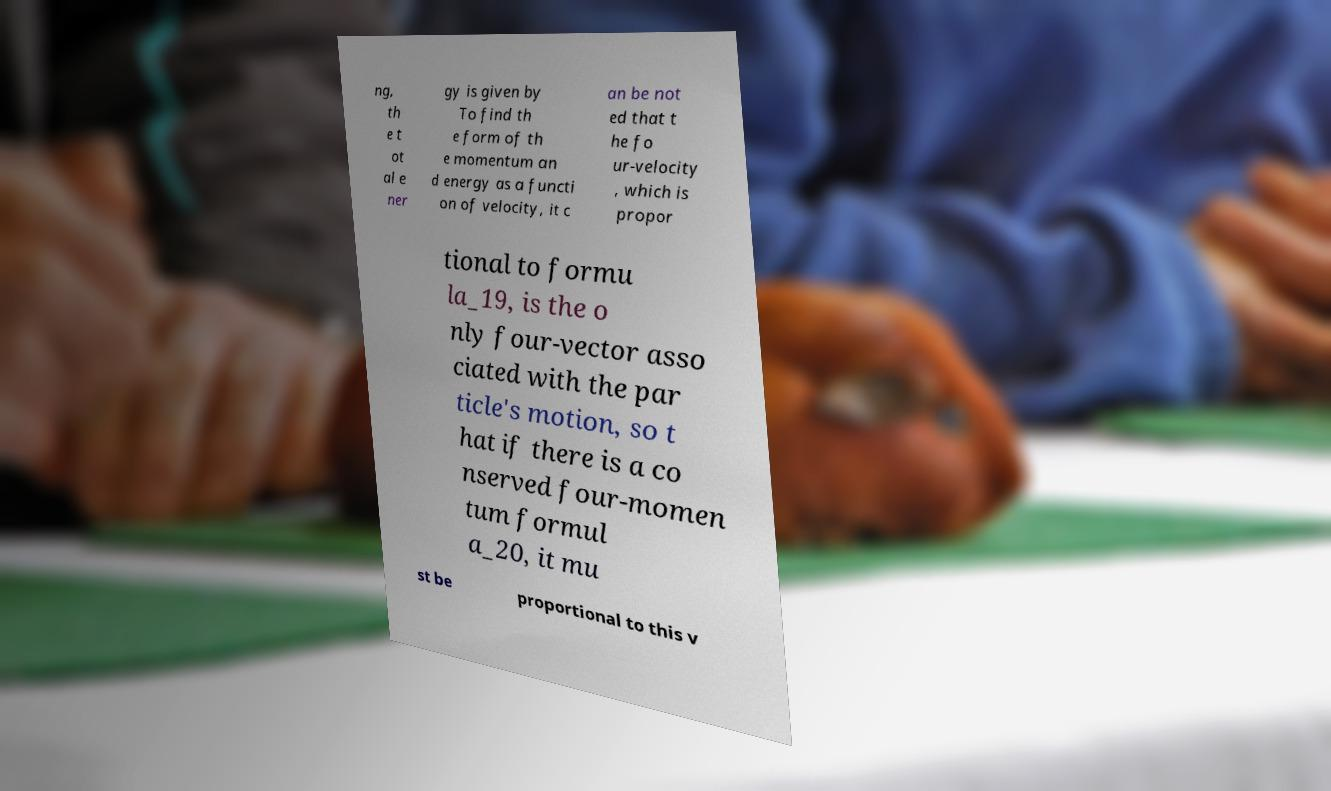Please read and relay the text visible in this image. What does it say? ng, th e t ot al e ner gy is given by To find th e form of th e momentum an d energy as a functi on of velocity, it c an be not ed that t he fo ur-velocity , which is propor tional to formu la_19, is the o nly four-vector asso ciated with the par ticle's motion, so t hat if there is a co nserved four-momen tum formul a_20, it mu st be proportional to this v 